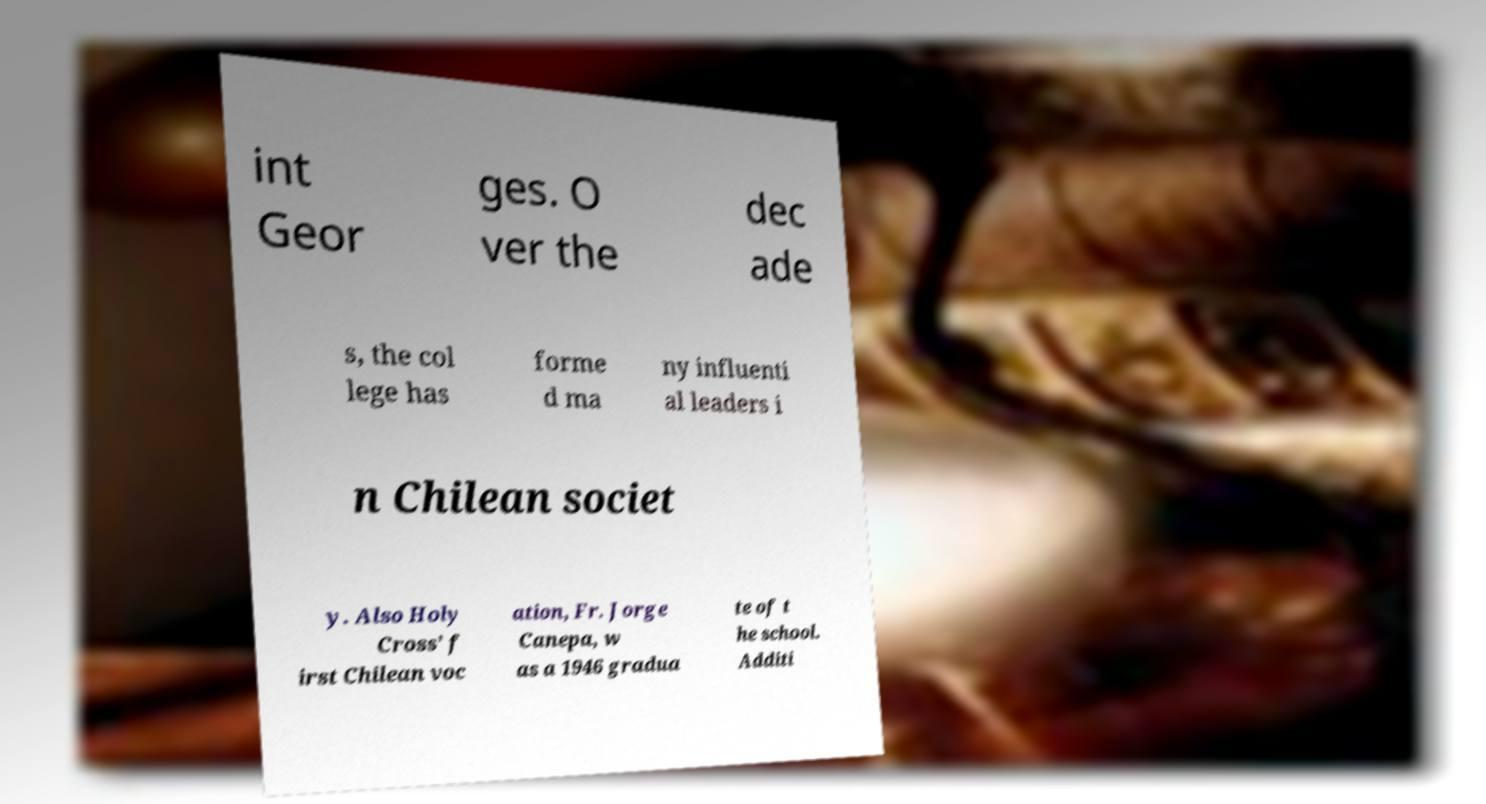Can you accurately transcribe the text from the provided image for me? int Geor ges. O ver the dec ade s, the col lege has forme d ma ny influenti al leaders i n Chilean societ y. Also Holy Cross’ f irst Chilean voc ation, Fr. Jorge Canepa, w as a 1946 gradua te of t he school. Additi 